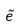Convert formula to latex. <formula><loc_0><loc_0><loc_500><loc_500>\tilde { e }</formula> 